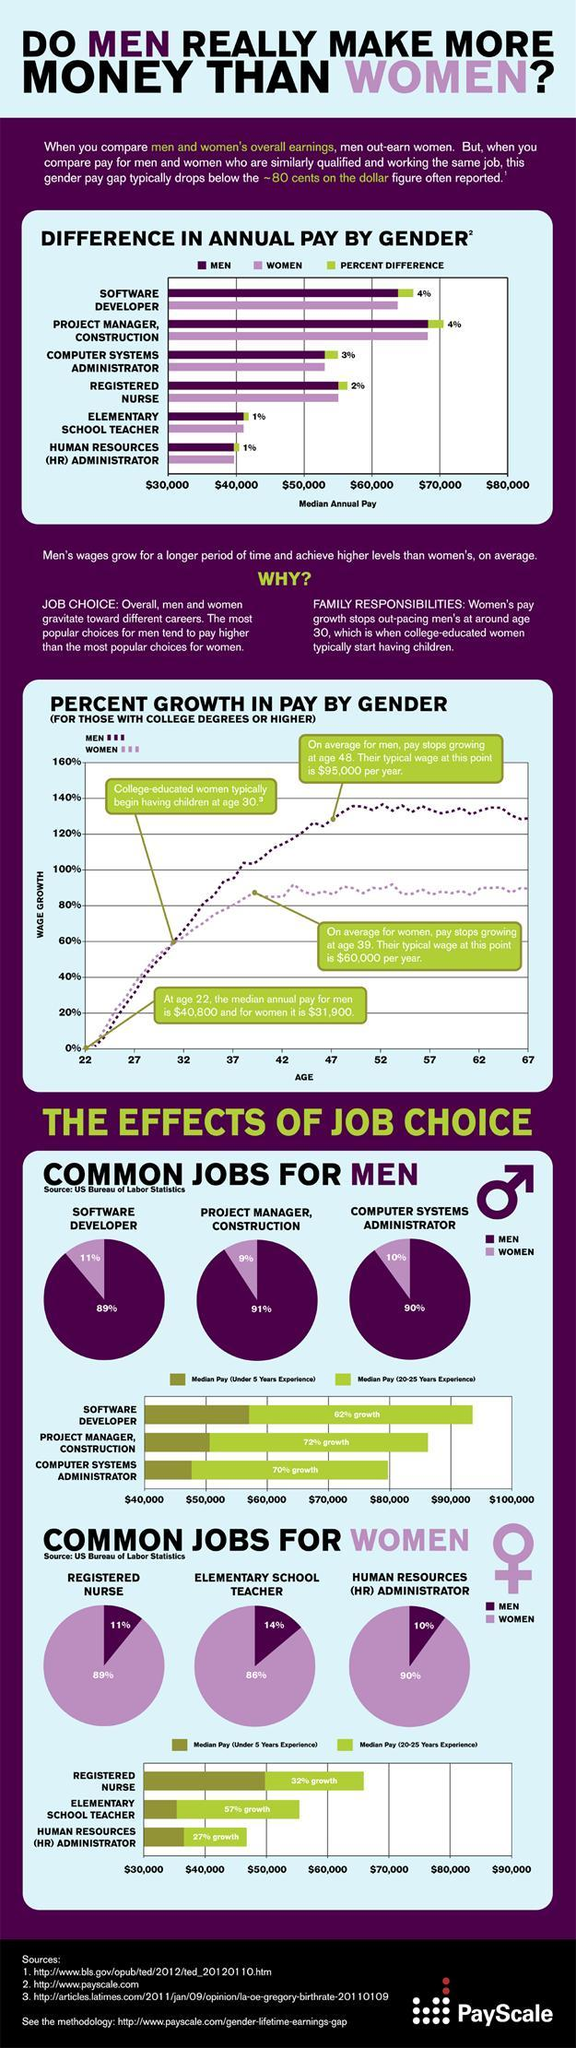What is the median pay a project manager would get if the experience is less than five years?
Answer the question with a short phrase. $51,000 What percentage of women are likely to choose the field of system administration? 10% Which roles have a median pay more than $ 40,000? Registered Nurse What is the difference in pay of a male and female nurse? $ 2,000 What is the percentage gap in the pays of men  and women in the role of school teacher and HR administrator? 1% By how much has the median annual pay of a woman increased in 17 years? $ 28,100 What is pay difference between men and women during the initial stage of their careers? $8,900 Which field would most women prefer to work, nursing, teaching or HR administration? HR administration 